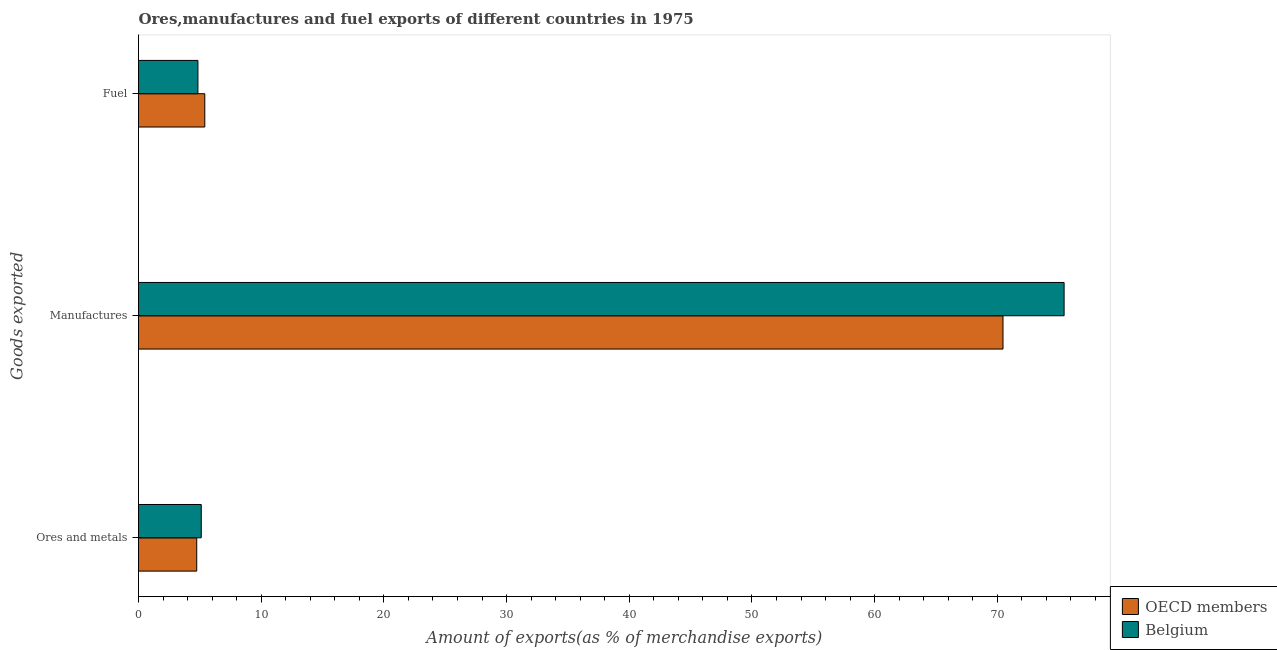How many groups of bars are there?
Provide a succinct answer. 3. Are the number of bars per tick equal to the number of legend labels?
Offer a terse response. Yes. Are the number of bars on each tick of the Y-axis equal?
Your answer should be compact. Yes. What is the label of the 2nd group of bars from the top?
Make the answer very short. Manufactures. What is the percentage of ores and metals exports in Belgium?
Your answer should be compact. 5.11. Across all countries, what is the maximum percentage of manufactures exports?
Provide a short and direct response. 75.44. Across all countries, what is the minimum percentage of ores and metals exports?
Keep it short and to the point. 4.74. In which country was the percentage of manufactures exports minimum?
Give a very brief answer. OECD members. What is the total percentage of ores and metals exports in the graph?
Your response must be concise. 9.86. What is the difference between the percentage of fuel exports in Belgium and that in OECD members?
Your answer should be compact. -0.56. What is the difference between the percentage of manufactures exports in Belgium and the percentage of fuel exports in OECD members?
Your answer should be compact. 70.04. What is the average percentage of fuel exports per country?
Give a very brief answer. 5.12. What is the difference between the percentage of manufactures exports and percentage of fuel exports in Belgium?
Your answer should be compact. 70.6. What is the ratio of the percentage of manufactures exports in OECD members to that in Belgium?
Your answer should be compact. 0.93. Is the percentage of ores and metals exports in OECD members less than that in Belgium?
Ensure brevity in your answer.  Yes. What is the difference between the highest and the second highest percentage of ores and metals exports?
Your response must be concise. 0.37. What is the difference between the highest and the lowest percentage of fuel exports?
Ensure brevity in your answer.  0.56. In how many countries, is the percentage of ores and metals exports greater than the average percentage of ores and metals exports taken over all countries?
Provide a succinct answer. 1. What does the 2nd bar from the top in Manufactures represents?
Make the answer very short. OECD members. What does the 1st bar from the bottom in Manufactures represents?
Offer a terse response. OECD members. Is it the case that in every country, the sum of the percentage of ores and metals exports and percentage of manufactures exports is greater than the percentage of fuel exports?
Keep it short and to the point. Yes. Are all the bars in the graph horizontal?
Offer a terse response. Yes. How many countries are there in the graph?
Ensure brevity in your answer.  2. What is the difference between two consecutive major ticks on the X-axis?
Your response must be concise. 10. Are the values on the major ticks of X-axis written in scientific E-notation?
Give a very brief answer. No. Does the graph contain any zero values?
Provide a short and direct response. No. Does the graph contain grids?
Provide a short and direct response. No. How many legend labels are there?
Provide a succinct answer. 2. How are the legend labels stacked?
Offer a very short reply. Vertical. What is the title of the graph?
Your answer should be very brief. Ores,manufactures and fuel exports of different countries in 1975. Does "Estonia" appear as one of the legend labels in the graph?
Provide a succinct answer. No. What is the label or title of the X-axis?
Offer a very short reply. Amount of exports(as % of merchandise exports). What is the label or title of the Y-axis?
Offer a terse response. Goods exported. What is the Amount of exports(as % of merchandise exports) in OECD members in Ores and metals?
Provide a short and direct response. 4.74. What is the Amount of exports(as % of merchandise exports) in Belgium in Ores and metals?
Give a very brief answer. 5.11. What is the Amount of exports(as % of merchandise exports) of OECD members in Manufactures?
Provide a short and direct response. 70.46. What is the Amount of exports(as % of merchandise exports) of Belgium in Manufactures?
Offer a very short reply. 75.44. What is the Amount of exports(as % of merchandise exports) of OECD members in Fuel?
Your answer should be compact. 5.4. What is the Amount of exports(as % of merchandise exports) in Belgium in Fuel?
Provide a short and direct response. 4.84. Across all Goods exported, what is the maximum Amount of exports(as % of merchandise exports) of OECD members?
Provide a succinct answer. 70.46. Across all Goods exported, what is the maximum Amount of exports(as % of merchandise exports) in Belgium?
Make the answer very short. 75.44. Across all Goods exported, what is the minimum Amount of exports(as % of merchandise exports) of OECD members?
Provide a succinct answer. 4.74. Across all Goods exported, what is the minimum Amount of exports(as % of merchandise exports) in Belgium?
Give a very brief answer. 4.84. What is the total Amount of exports(as % of merchandise exports) in OECD members in the graph?
Ensure brevity in your answer.  80.61. What is the total Amount of exports(as % of merchandise exports) of Belgium in the graph?
Provide a succinct answer. 85.4. What is the difference between the Amount of exports(as % of merchandise exports) of OECD members in Ores and metals and that in Manufactures?
Give a very brief answer. -65.72. What is the difference between the Amount of exports(as % of merchandise exports) in Belgium in Ores and metals and that in Manufactures?
Make the answer very short. -70.33. What is the difference between the Amount of exports(as % of merchandise exports) in OECD members in Ores and metals and that in Fuel?
Ensure brevity in your answer.  -0.66. What is the difference between the Amount of exports(as % of merchandise exports) of Belgium in Ores and metals and that in Fuel?
Keep it short and to the point. 0.27. What is the difference between the Amount of exports(as % of merchandise exports) of OECD members in Manufactures and that in Fuel?
Your answer should be compact. 65.06. What is the difference between the Amount of exports(as % of merchandise exports) in Belgium in Manufactures and that in Fuel?
Your answer should be very brief. 70.6. What is the difference between the Amount of exports(as % of merchandise exports) of OECD members in Ores and metals and the Amount of exports(as % of merchandise exports) of Belgium in Manufactures?
Provide a succinct answer. -70.7. What is the difference between the Amount of exports(as % of merchandise exports) of OECD members in Ores and metals and the Amount of exports(as % of merchandise exports) of Belgium in Fuel?
Your answer should be compact. -0.1. What is the difference between the Amount of exports(as % of merchandise exports) of OECD members in Manufactures and the Amount of exports(as % of merchandise exports) of Belgium in Fuel?
Make the answer very short. 65.62. What is the average Amount of exports(as % of merchandise exports) in OECD members per Goods exported?
Offer a terse response. 26.87. What is the average Amount of exports(as % of merchandise exports) in Belgium per Goods exported?
Your answer should be compact. 28.47. What is the difference between the Amount of exports(as % of merchandise exports) in OECD members and Amount of exports(as % of merchandise exports) in Belgium in Ores and metals?
Make the answer very short. -0.37. What is the difference between the Amount of exports(as % of merchandise exports) in OECD members and Amount of exports(as % of merchandise exports) in Belgium in Manufactures?
Your answer should be compact. -4.98. What is the difference between the Amount of exports(as % of merchandise exports) in OECD members and Amount of exports(as % of merchandise exports) in Belgium in Fuel?
Ensure brevity in your answer.  0.56. What is the ratio of the Amount of exports(as % of merchandise exports) in OECD members in Ores and metals to that in Manufactures?
Offer a very short reply. 0.07. What is the ratio of the Amount of exports(as % of merchandise exports) of Belgium in Ores and metals to that in Manufactures?
Give a very brief answer. 0.07. What is the ratio of the Amount of exports(as % of merchandise exports) in OECD members in Ores and metals to that in Fuel?
Provide a succinct answer. 0.88. What is the ratio of the Amount of exports(as % of merchandise exports) in Belgium in Ores and metals to that in Fuel?
Offer a very short reply. 1.06. What is the ratio of the Amount of exports(as % of merchandise exports) of OECD members in Manufactures to that in Fuel?
Ensure brevity in your answer.  13.04. What is the ratio of the Amount of exports(as % of merchandise exports) of Belgium in Manufactures to that in Fuel?
Provide a short and direct response. 15.58. What is the difference between the highest and the second highest Amount of exports(as % of merchandise exports) of OECD members?
Your answer should be compact. 65.06. What is the difference between the highest and the second highest Amount of exports(as % of merchandise exports) in Belgium?
Offer a very short reply. 70.33. What is the difference between the highest and the lowest Amount of exports(as % of merchandise exports) in OECD members?
Keep it short and to the point. 65.72. What is the difference between the highest and the lowest Amount of exports(as % of merchandise exports) in Belgium?
Keep it short and to the point. 70.6. 